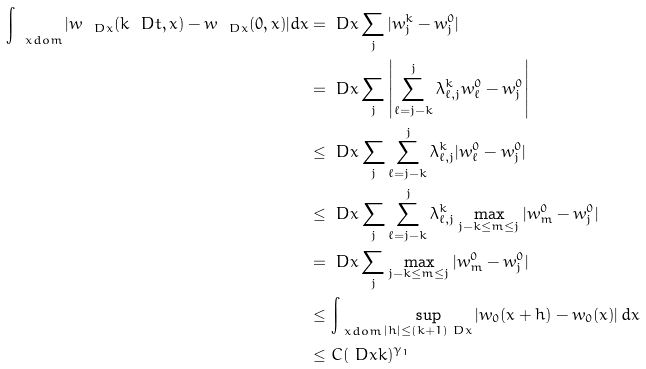<formula> <loc_0><loc_0><loc_500><loc_500>\int _ { \ x d o m } | w _ { \ D x } ( k \ D t , x ) - w _ { \ D x } ( 0 , x ) | d x & = \ D x \sum _ { j } | w ^ { k } _ { j } - w ^ { 0 } _ { j } | \\ & = \ D x \sum _ { j } \left | \sum _ { \ell = j - k } ^ { j } \lambda ^ { k } _ { \ell , j } w ^ { 0 } _ { \ell } - w ^ { 0 } _ { j } \right | \\ & \leq \ D x \sum _ { j } \sum _ { \ell = j - k } ^ { j } \lambda ^ { k } _ { \ell , j } | w ^ { 0 } _ { \ell } - w ^ { 0 } _ { j } | \\ & \leq \ D x \sum _ { j } \sum _ { \ell = j - k } ^ { j } \lambda ^ { k } _ { \ell , j } \max _ { j - k \leq m \leq j } | w ^ { 0 } _ { m } - w ^ { 0 } _ { j } | \\ & = \ D x \sum _ { j } \max _ { j - k \leq m \leq j } | w ^ { 0 } _ { m } - w ^ { 0 } _ { j } | \\ & \leq \int _ { \ x d o m } \sup _ { | h | \leq ( k + 1 ) \ D x } | w _ { 0 } ( x + h ) - w _ { 0 } ( x ) | \, d x \\ & \leq C ( \ D x k ) ^ { \gamma _ { 1 } }</formula> 